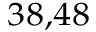<formula> <loc_0><loc_0><loc_500><loc_500>^ { 3 8 , 4 8 }</formula> 